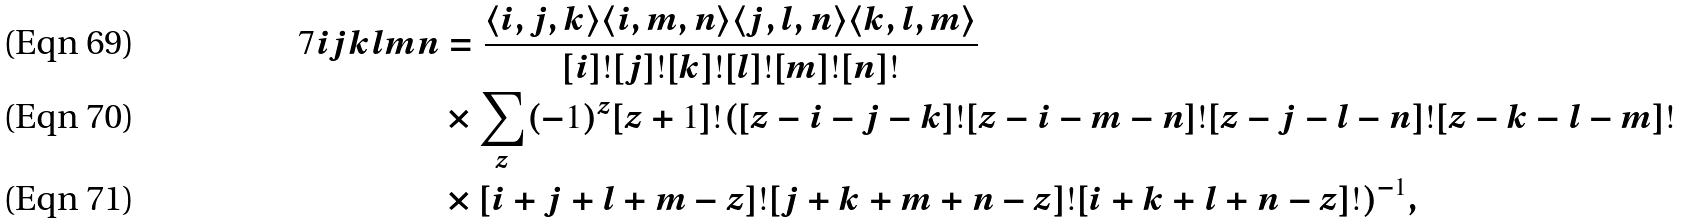<formula> <loc_0><loc_0><loc_500><loc_500>\ 7 { i } { j } { k } { l } { m } { n } & = \frac { \langle i , j , k \rangle \langle i , m , n \rangle \langle j , l , n \rangle \langle k , l , m \rangle } { [ i ] ! [ j ] ! [ k ] ! [ l ] ! [ m ] ! [ n ] ! } \\ & \times \sum _ { z } ( - 1 ) ^ { z } [ z + 1 ] ! ( [ z - i - j - k ] ! [ z - i - m - n ] ! [ z - j - l - n ] ! [ z - k - l - m ] ! \\ & \times [ i + j + l + m - z ] ! [ j + k + m + n - z ] ! [ i + k + l + n - z ] ! ) ^ { - 1 } ,</formula> 